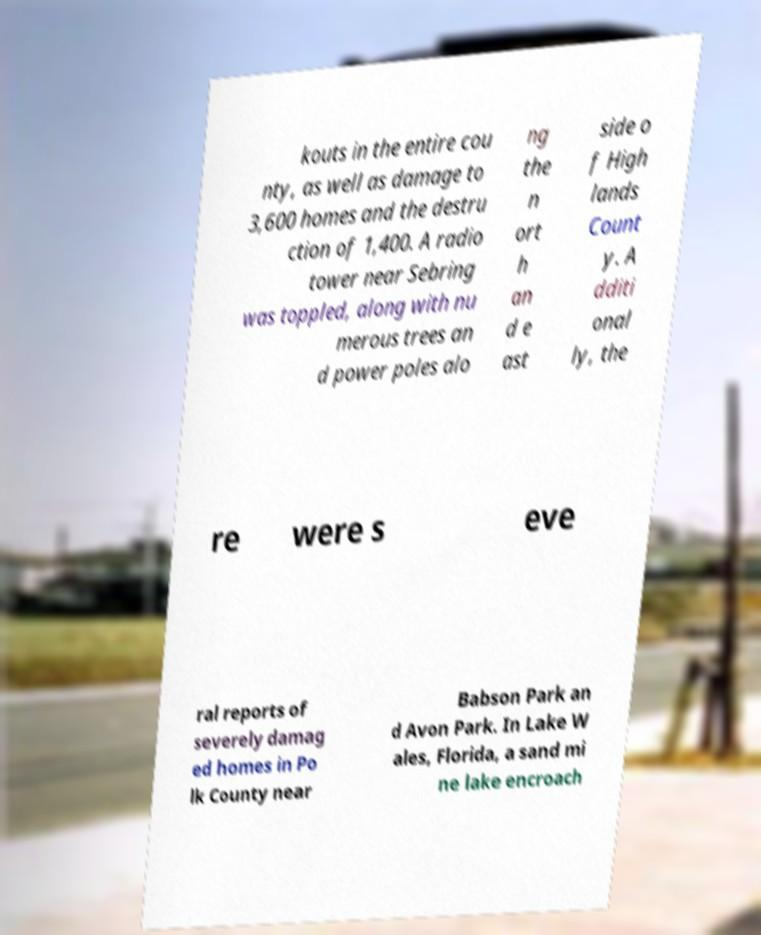Can you read and provide the text displayed in the image?This photo seems to have some interesting text. Can you extract and type it out for me? kouts in the entire cou nty, as well as damage to 3,600 homes and the destru ction of 1,400. A radio tower near Sebring was toppled, along with nu merous trees an d power poles alo ng the n ort h an d e ast side o f High lands Count y. A dditi onal ly, the re were s eve ral reports of severely damag ed homes in Po lk County near Babson Park an d Avon Park. In Lake W ales, Florida, a sand mi ne lake encroach 